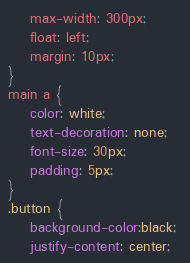<code> <loc_0><loc_0><loc_500><loc_500><_CSS_>    max-width: 300px;
    float: left;
    margin: 10px;
}
main a {
    color: white;
    text-decoration: none;
    font-size: 30px;
    padding: 5px;
}
.button {
    background-color:black; 
    justify-content: center;</code> 